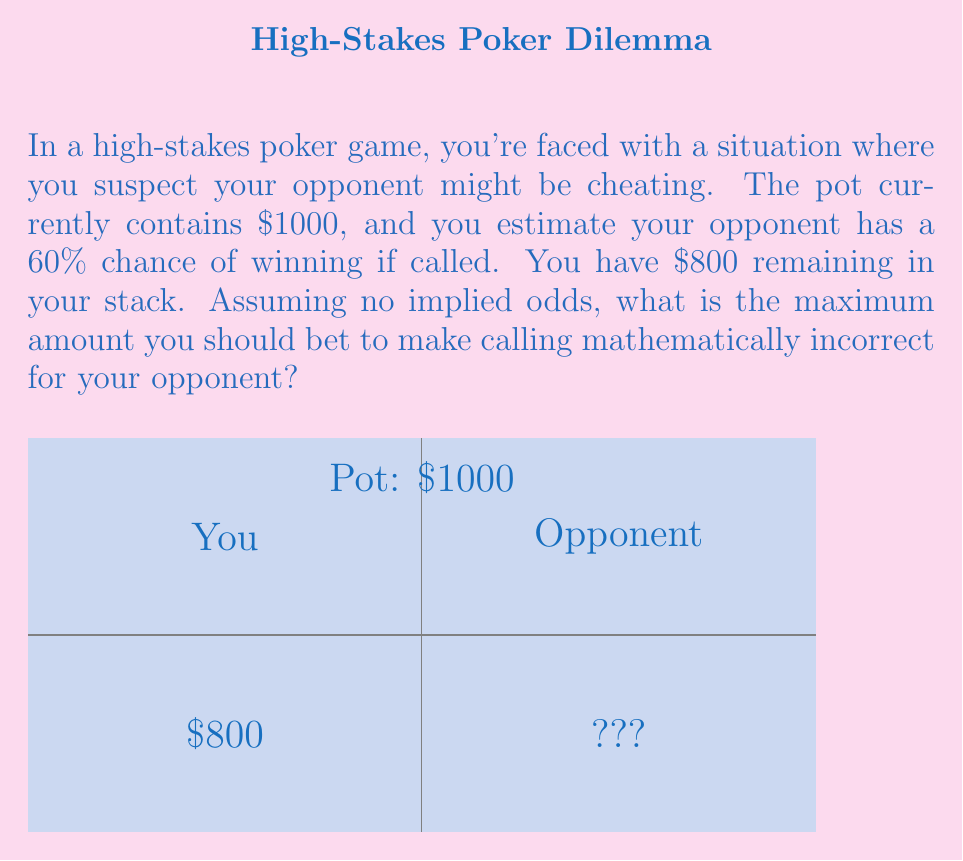Teach me how to tackle this problem. To solve this problem, we need to use the concept of pot odds and find the break-even point for our opponent. Here's a step-by-step explanation:

1) First, let's define our variables:
   $x$ = our bet amount
   $P$ = current pot size = $1000
   $p$ = opponent's probability of winning = 0.6

2) For our opponent to break even, their expected value (EV) should be zero:

   $EV = p(P + x) - x = 0$

3) Expanding this equation:
   $0.6(1000 + x) - x = 0$

4) Simplify:
   $600 + 0.6x - x = 0$
   $600 - 0.4x = 0$

5) Solve for $x$:
   $0.4x = 600$
   $x = 1500$

6) However, we only have $800 in our stack. Therefore, the maximum amount we can bet is $800.

7) To verify, let's calculate our opponent's EV if we bet $800:
   $EV = 0.6(1000 + 800) - 800 = 280$

   This is positive, meaning our opponent would still be correct to call if we bet our entire stack.

8) The optimal bet size to make calling mathematically incorrect would be any amount greater than $1500, but we're limited by our stack size.
Answer: $800 (full stack) 